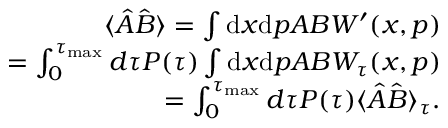Convert formula to latex. <formula><loc_0><loc_0><loc_500><loc_500>\begin{array} { r l r } & { \langle \hat { A } \hat { B } \rangle = \int d x d p A B W ^ { \prime } ( x , p ) } \\ & { = \int _ { 0 } ^ { \tau _ { \max } } d \tau P ( \tau ) \int d x d p A B W _ { \tau } ( x , p ) } \\ & { = \int _ { 0 } ^ { \tau _ { \max } } d \tau P ( \tau ) \langle \hat { A } \hat { B } \rangle _ { \tau } . } \end{array}</formula> 